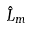<formula> <loc_0><loc_0><loc_500><loc_500>\hat { L } _ { m }</formula> 